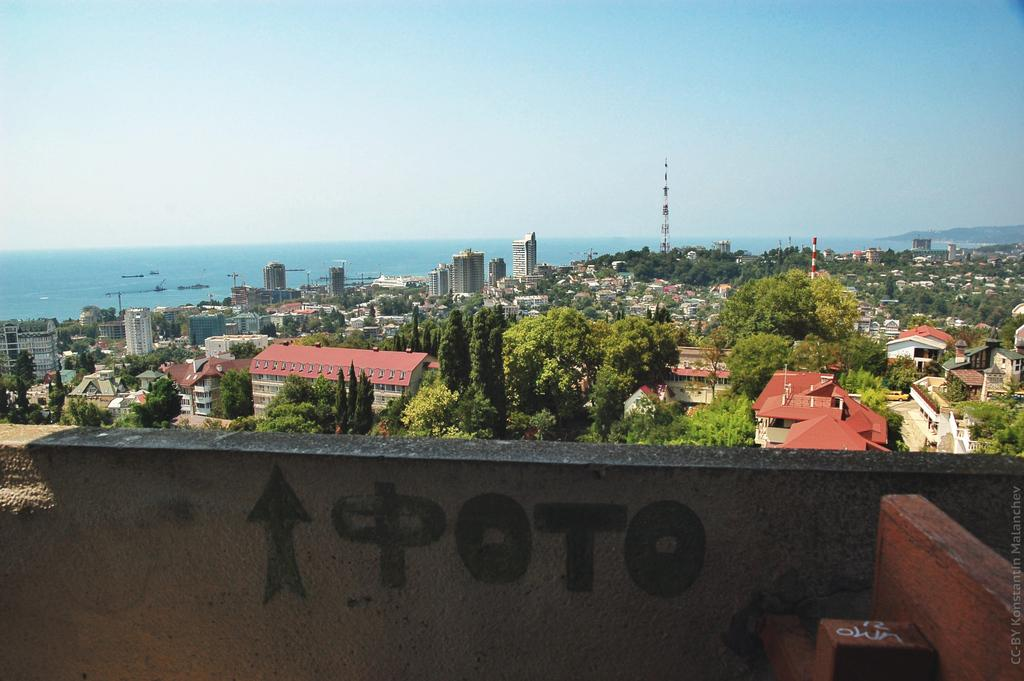What type of structures can be seen in the image? There are buildings in the image. What natural elements are present in the image? There are trees in the image. What architectural feature is visible in the image? There is a wall in the image. What can be seen in the distance in the image? There is water visible in the background of the image. What color is the sky in the background of the image? The sky is blue in the background of the image. Can you see any grapes hanging from the trees in the image? There are no grapes visible in the image; the trees are not identified as fruit-bearing trees. Is there an owl perched on the wall in the image? There is no owl present in the image; only the buildings, trees, wall, water, and sky are visible. 